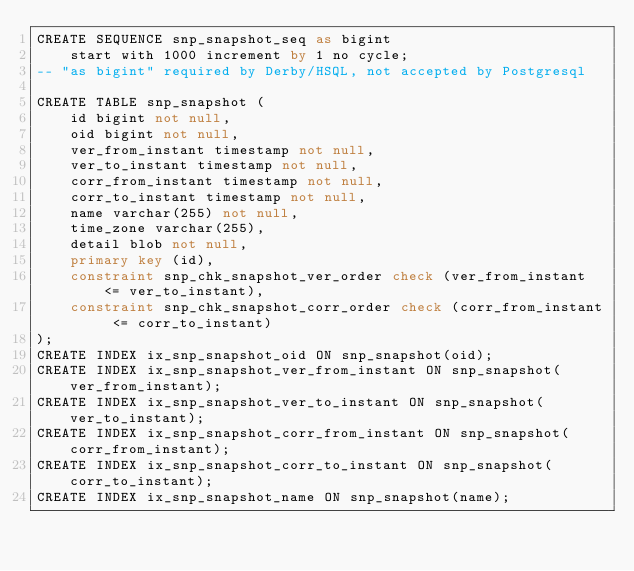Convert code to text. <code><loc_0><loc_0><loc_500><loc_500><_SQL_>CREATE SEQUENCE snp_snapshot_seq as bigint
    start with 1000 increment by 1 no cycle;
-- "as bigint" required by Derby/HSQL, not accepted by Postgresql

CREATE TABLE snp_snapshot (
    id bigint not null,
    oid bigint not null,
    ver_from_instant timestamp not null,
    ver_to_instant timestamp not null,
    corr_from_instant timestamp not null,
    corr_to_instant timestamp not null,
    name varchar(255) not null,
    time_zone varchar(255),
    detail blob not null,
    primary key (id),
    constraint snp_chk_snapshot_ver_order check (ver_from_instant <= ver_to_instant),
    constraint snp_chk_snapshot_corr_order check (corr_from_instant <= corr_to_instant)
);
CREATE INDEX ix_snp_snapshot_oid ON snp_snapshot(oid);
CREATE INDEX ix_snp_snapshot_ver_from_instant ON snp_snapshot(ver_from_instant);
CREATE INDEX ix_snp_snapshot_ver_to_instant ON snp_snapshot(ver_to_instant);
CREATE INDEX ix_snp_snapshot_corr_from_instant ON snp_snapshot(corr_from_instant);
CREATE INDEX ix_snp_snapshot_corr_to_instant ON snp_snapshot(corr_to_instant);
CREATE INDEX ix_snp_snapshot_name ON snp_snapshot(name);</code> 